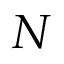Convert formula to latex. <formula><loc_0><loc_0><loc_500><loc_500>N</formula> 